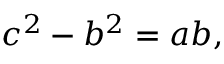Convert formula to latex. <formula><loc_0><loc_0><loc_500><loc_500>c ^ { 2 } - b ^ { 2 } = a b ,</formula> 